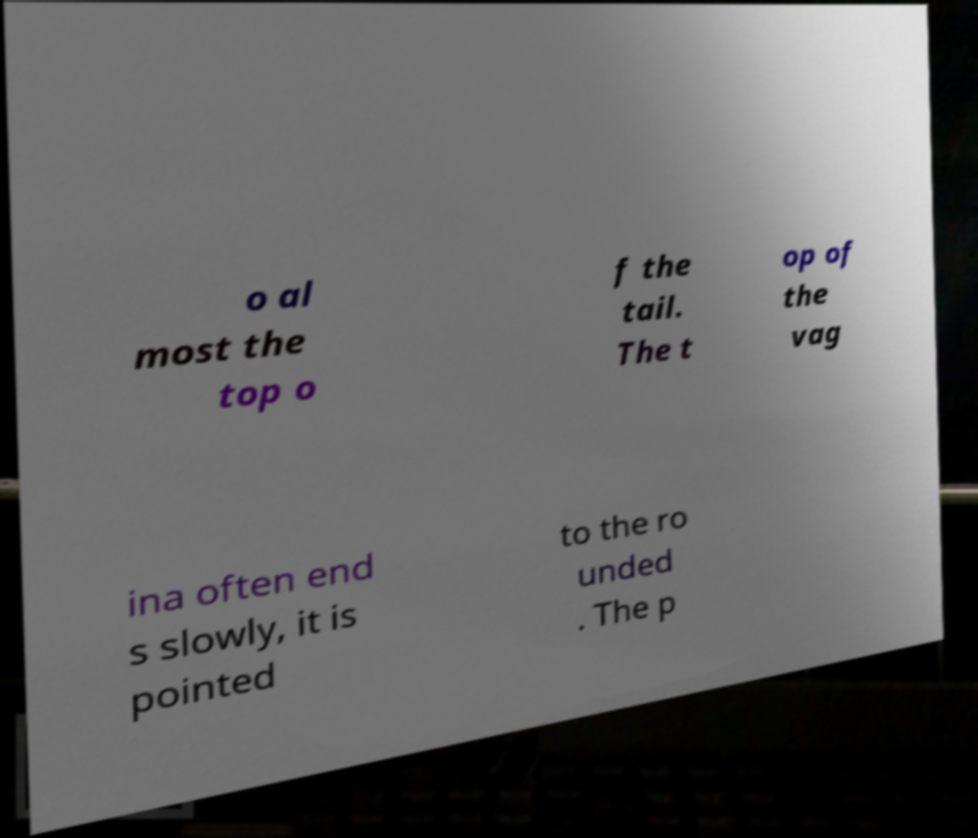Can you read and provide the text displayed in the image?This photo seems to have some interesting text. Can you extract and type it out for me? o al most the top o f the tail. The t op of the vag ina often end s slowly, it is pointed to the ro unded . The p 